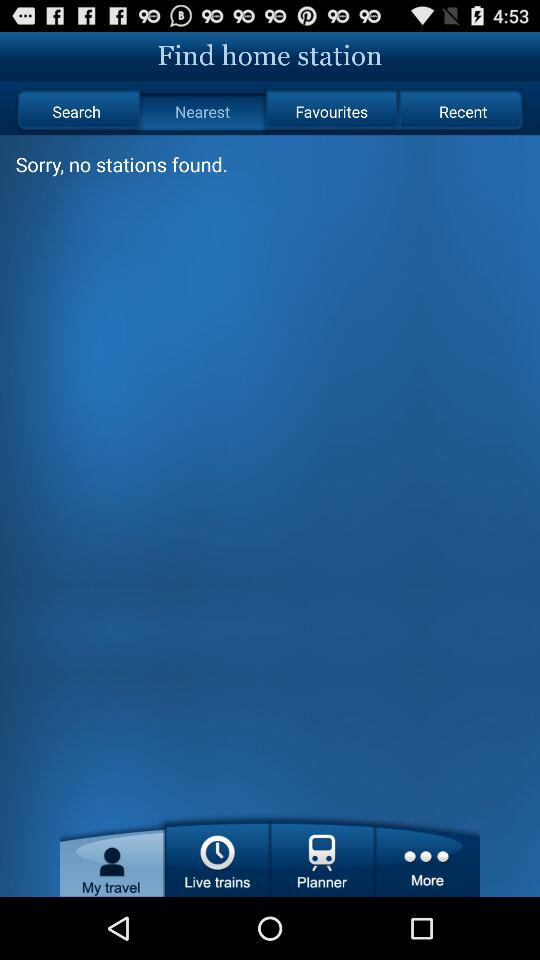Are there any stations found? There are no stations found. 